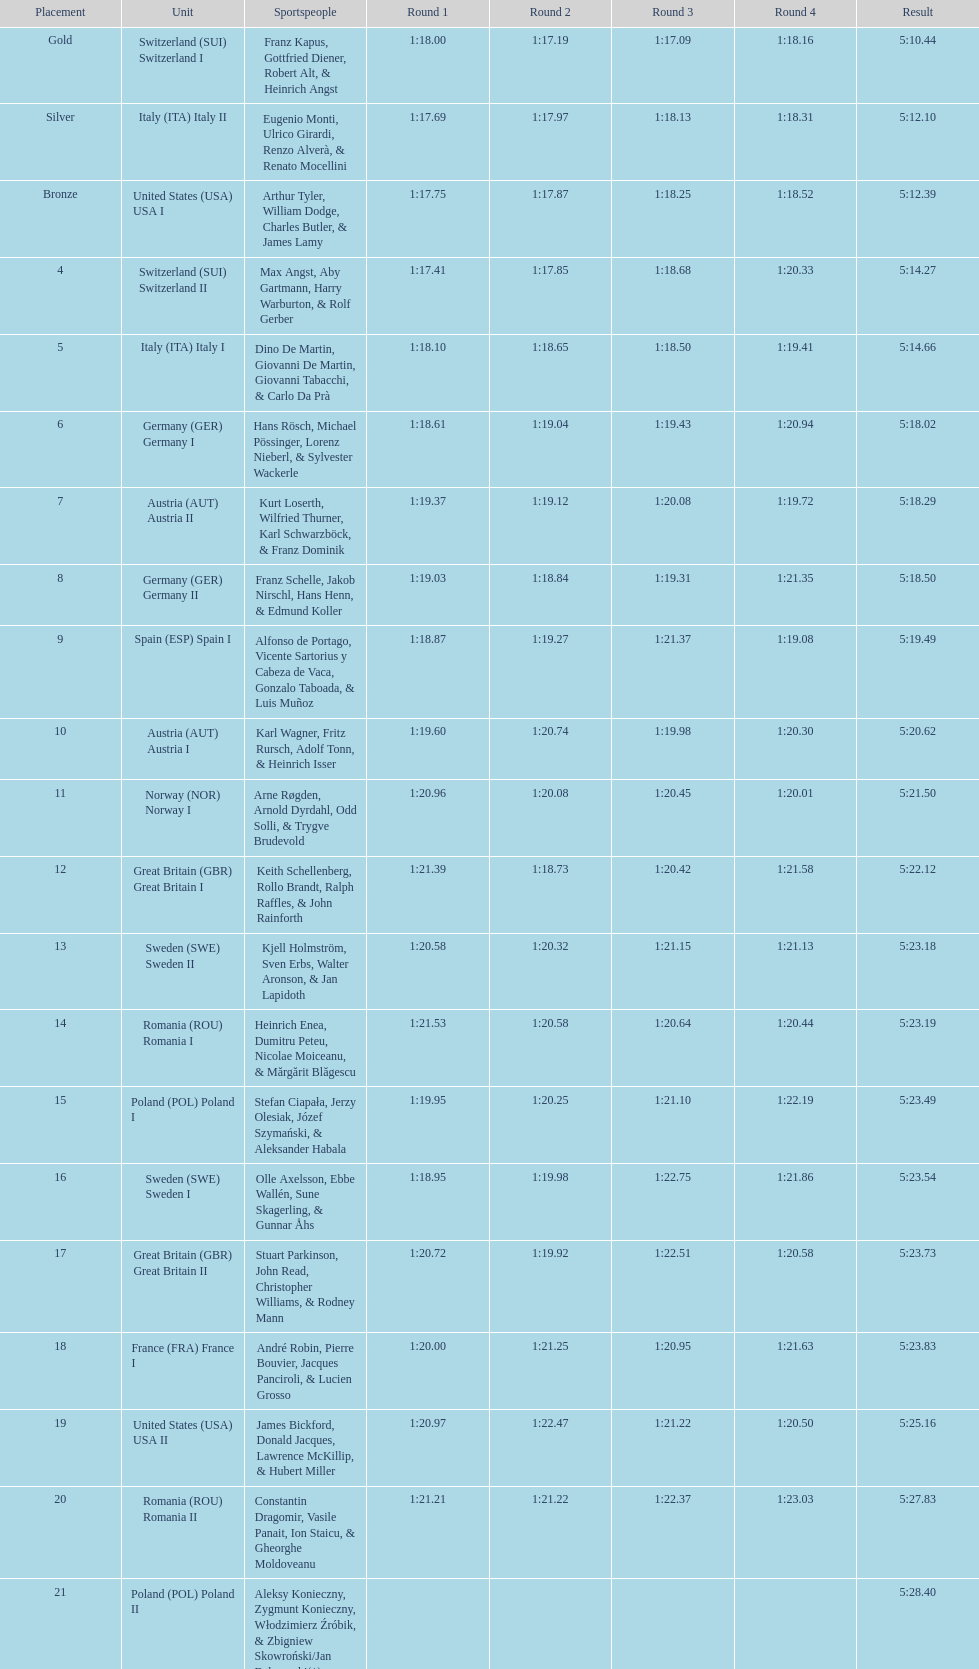Which team follows italy (ita) italy i? Germany I. 